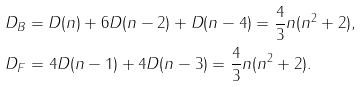<formula> <loc_0><loc_0><loc_500><loc_500>& D _ { B } = D ( n ) + 6 D ( n - 2 ) + D ( n - 4 ) = \frac { 4 } { 3 } n ( n ^ { 2 } + 2 ) , \\ & D _ { F } = 4 D ( n - 1 ) + 4 D ( n - 3 ) = \frac { 4 } { 3 } n ( n ^ { 2 } + 2 ) .</formula> 